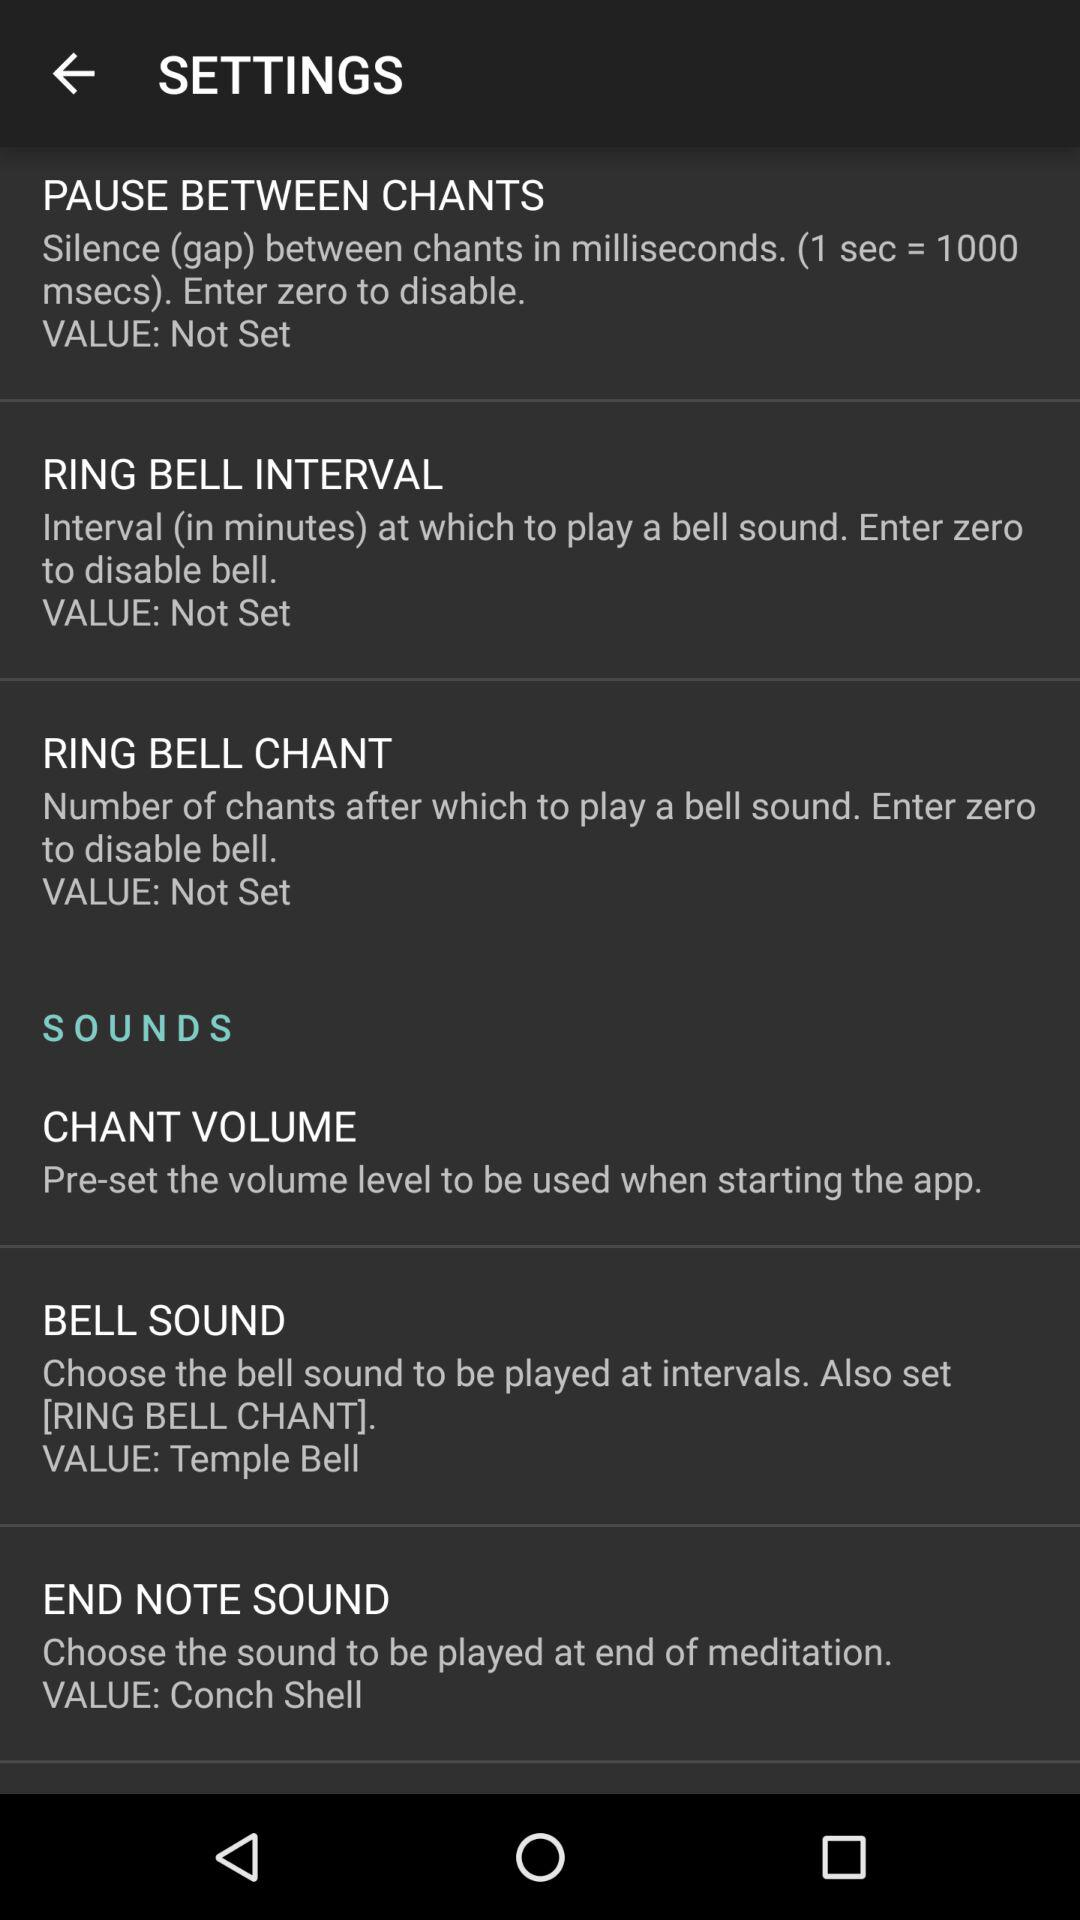Is there any value set for the Ring Bell Chant? The value set for the Ring Bell Chant is "Not Set". 